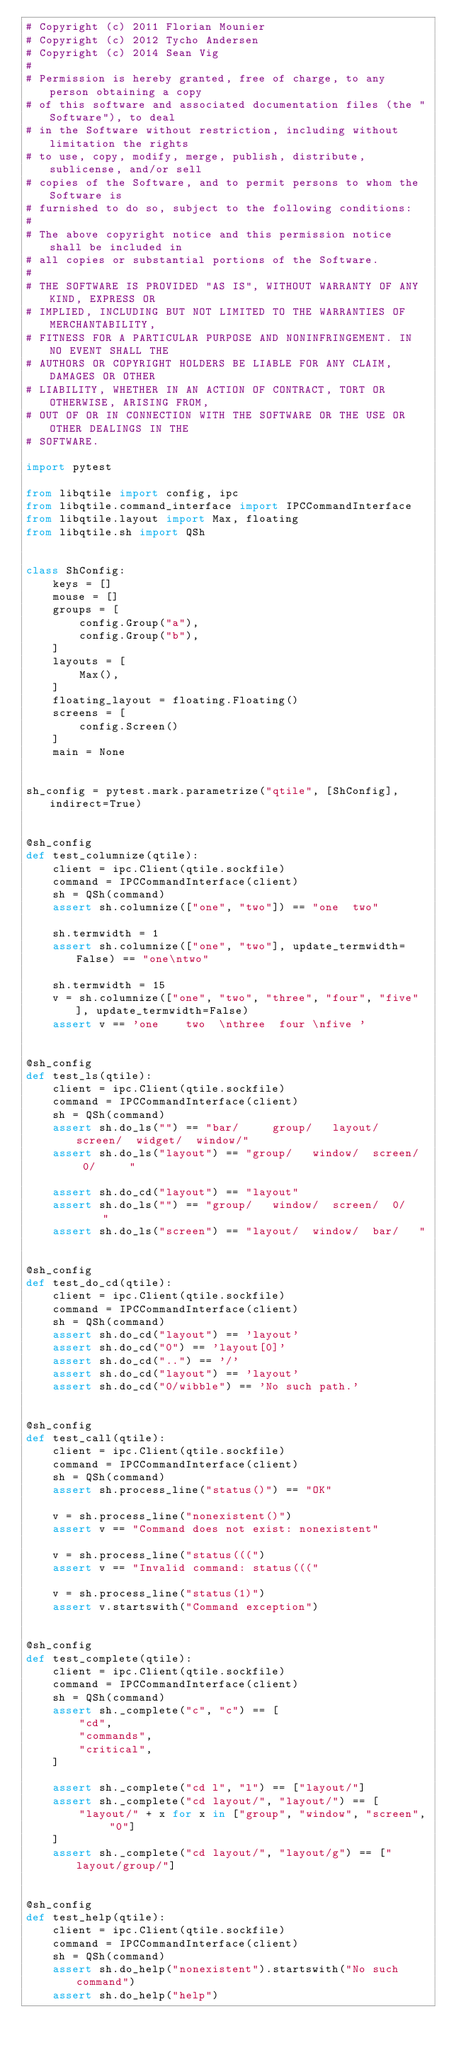Convert code to text. <code><loc_0><loc_0><loc_500><loc_500><_Python_># Copyright (c) 2011 Florian Mounier
# Copyright (c) 2012 Tycho Andersen
# Copyright (c) 2014 Sean Vig
#
# Permission is hereby granted, free of charge, to any person obtaining a copy
# of this software and associated documentation files (the "Software"), to deal
# in the Software without restriction, including without limitation the rights
# to use, copy, modify, merge, publish, distribute, sublicense, and/or sell
# copies of the Software, and to permit persons to whom the Software is
# furnished to do so, subject to the following conditions:
#
# The above copyright notice and this permission notice shall be included in
# all copies or substantial portions of the Software.
#
# THE SOFTWARE IS PROVIDED "AS IS", WITHOUT WARRANTY OF ANY KIND, EXPRESS OR
# IMPLIED, INCLUDING BUT NOT LIMITED TO THE WARRANTIES OF MERCHANTABILITY,
# FITNESS FOR A PARTICULAR PURPOSE AND NONINFRINGEMENT. IN NO EVENT SHALL THE
# AUTHORS OR COPYRIGHT HOLDERS BE LIABLE FOR ANY CLAIM, DAMAGES OR OTHER
# LIABILITY, WHETHER IN AN ACTION OF CONTRACT, TORT OR OTHERWISE, ARISING FROM,
# OUT OF OR IN CONNECTION WITH THE SOFTWARE OR THE USE OR OTHER DEALINGS IN THE
# SOFTWARE.

import pytest

from libqtile import config, ipc
from libqtile.command_interface import IPCCommandInterface
from libqtile.layout import Max, floating
from libqtile.sh import QSh


class ShConfig:
    keys = []
    mouse = []
    groups = [
        config.Group("a"),
        config.Group("b"),
    ]
    layouts = [
        Max(),
    ]
    floating_layout = floating.Floating()
    screens = [
        config.Screen()
    ]
    main = None


sh_config = pytest.mark.parametrize("qtile", [ShConfig], indirect=True)


@sh_config
def test_columnize(qtile):
    client = ipc.Client(qtile.sockfile)
    command = IPCCommandInterface(client)
    sh = QSh(command)
    assert sh.columnize(["one", "two"]) == "one  two"

    sh.termwidth = 1
    assert sh.columnize(["one", "two"], update_termwidth=False) == "one\ntwo"

    sh.termwidth = 15
    v = sh.columnize(["one", "two", "three", "four", "five"], update_termwidth=False)
    assert v == 'one    two  \nthree  four \nfive '


@sh_config
def test_ls(qtile):
    client = ipc.Client(qtile.sockfile)
    command = IPCCommandInterface(client)
    sh = QSh(command)
    assert sh.do_ls("") == "bar/     group/   layout/  screen/  widget/  window/"
    assert sh.do_ls("layout") == "group/   window/  screen/  0/     "

    assert sh.do_cd("layout") == "layout"
    assert sh.do_ls("") == "group/   window/  screen/  0/     "
    assert sh.do_ls("screen") == "layout/  window/  bar/   "


@sh_config
def test_do_cd(qtile):
    client = ipc.Client(qtile.sockfile)
    command = IPCCommandInterface(client)
    sh = QSh(command)
    assert sh.do_cd("layout") == 'layout'
    assert sh.do_cd("0") == 'layout[0]'
    assert sh.do_cd("..") == '/'
    assert sh.do_cd("layout") == 'layout'
    assert sh.do_cd("0/wibble") == 'No such path.'


@sh_config
def test_call(qtile):
    client = ipc.Client(qtile.sockfile)
    command = IPCCommandInterface(client)
    sh = QSh(command)
    assert sh.process_line("status()") == "OK"

    v = sh.process_line("nonexistent()")
    assert v == "Command does not exist: nonexistent"

    v = sh.process_line("status(((")
    assert v == "Invalid command: status((("

    v = sh.process_line("status(1)")
    assert v.startswith("Command exception")


@sh_config
def test_complete(qtile):
    client = ipc.Client(qtile.sockfile)
    command = IPCCommandInterface(client)
    sh = QSh(command)
    assert sh._complete("c", "c") == [
        "cd",
        "commands",
        "critical",
    ]

    assert sh._complete("cd l", "l") == ["layout/"]
    assert sh._complete("cd layout/", "layout/") == [
        "layout/" + x for x in ["group", "window", "screen", "0"]
    ]
    assert sh._complete("cd layout/", "layout/g") == ["layout/group/"]


@sh_config
def test_help(qtile):
    client = ipc.Client(qtile.sockfile)
    command = IPCCommandInterface(client)
    sh = QSh(command)
    assert sh.do_help("nonexistent").startswith("No such command")
    assert sh.do_help("help")
</code> 